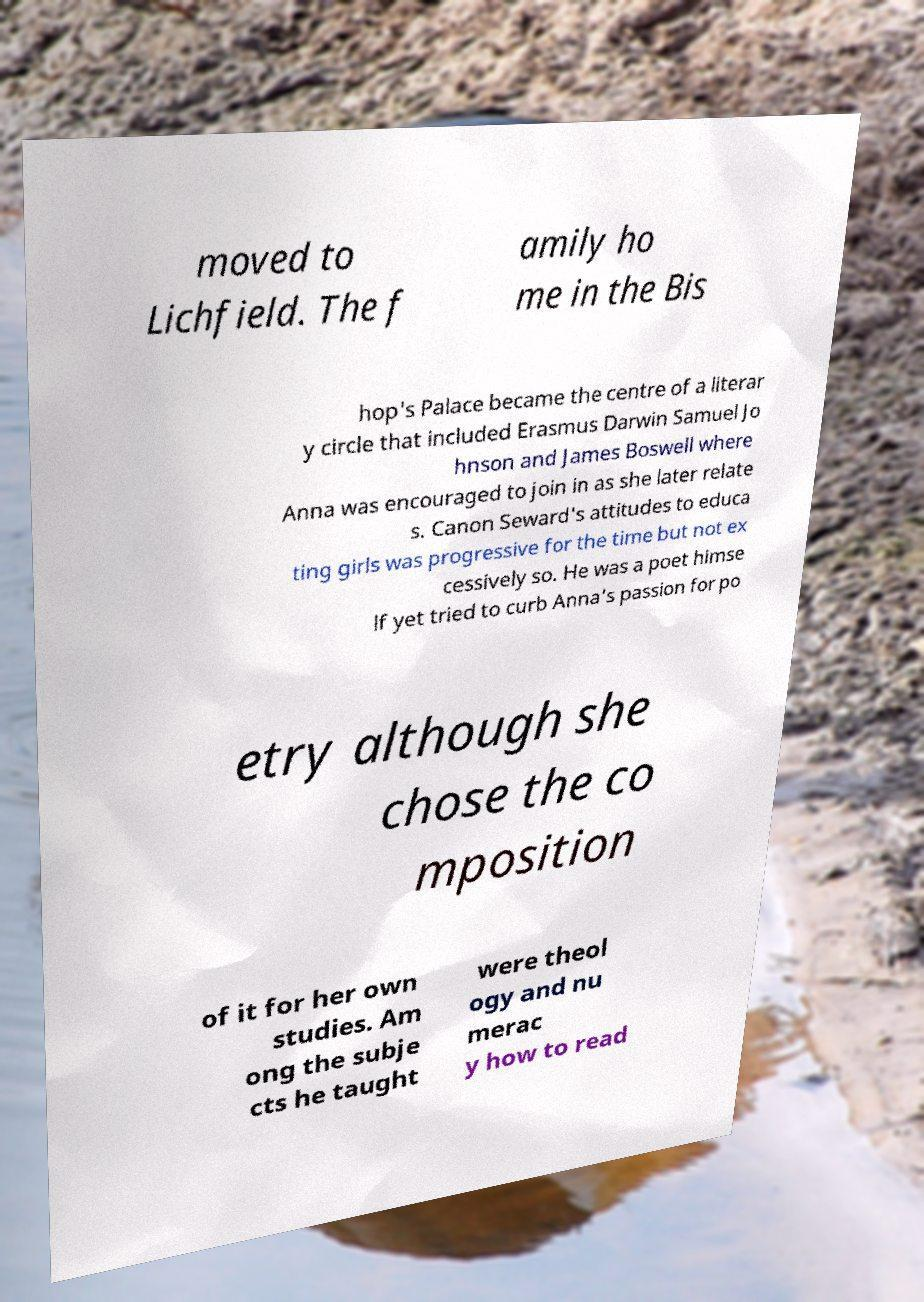I need the written content from this picture converted into text. Can you do that? moved to Lichfield. The f amily ho me in the Bis hop's Palace became the centre of a literar y circle that included Erasmus Darwin Samuel Jo hnson and James Boswell where Anna was encouraged to join in as she later relate s. Canon Seward's attitudes to educa ting girls was progressive for the time but not ex cessively so. He was a poet himse lf yet tried to curb Anna's passion for po etry although she chose the co mposition of it for her own studies. Am ong the subje cts he taught were theol ogy and nu merac y how to read 